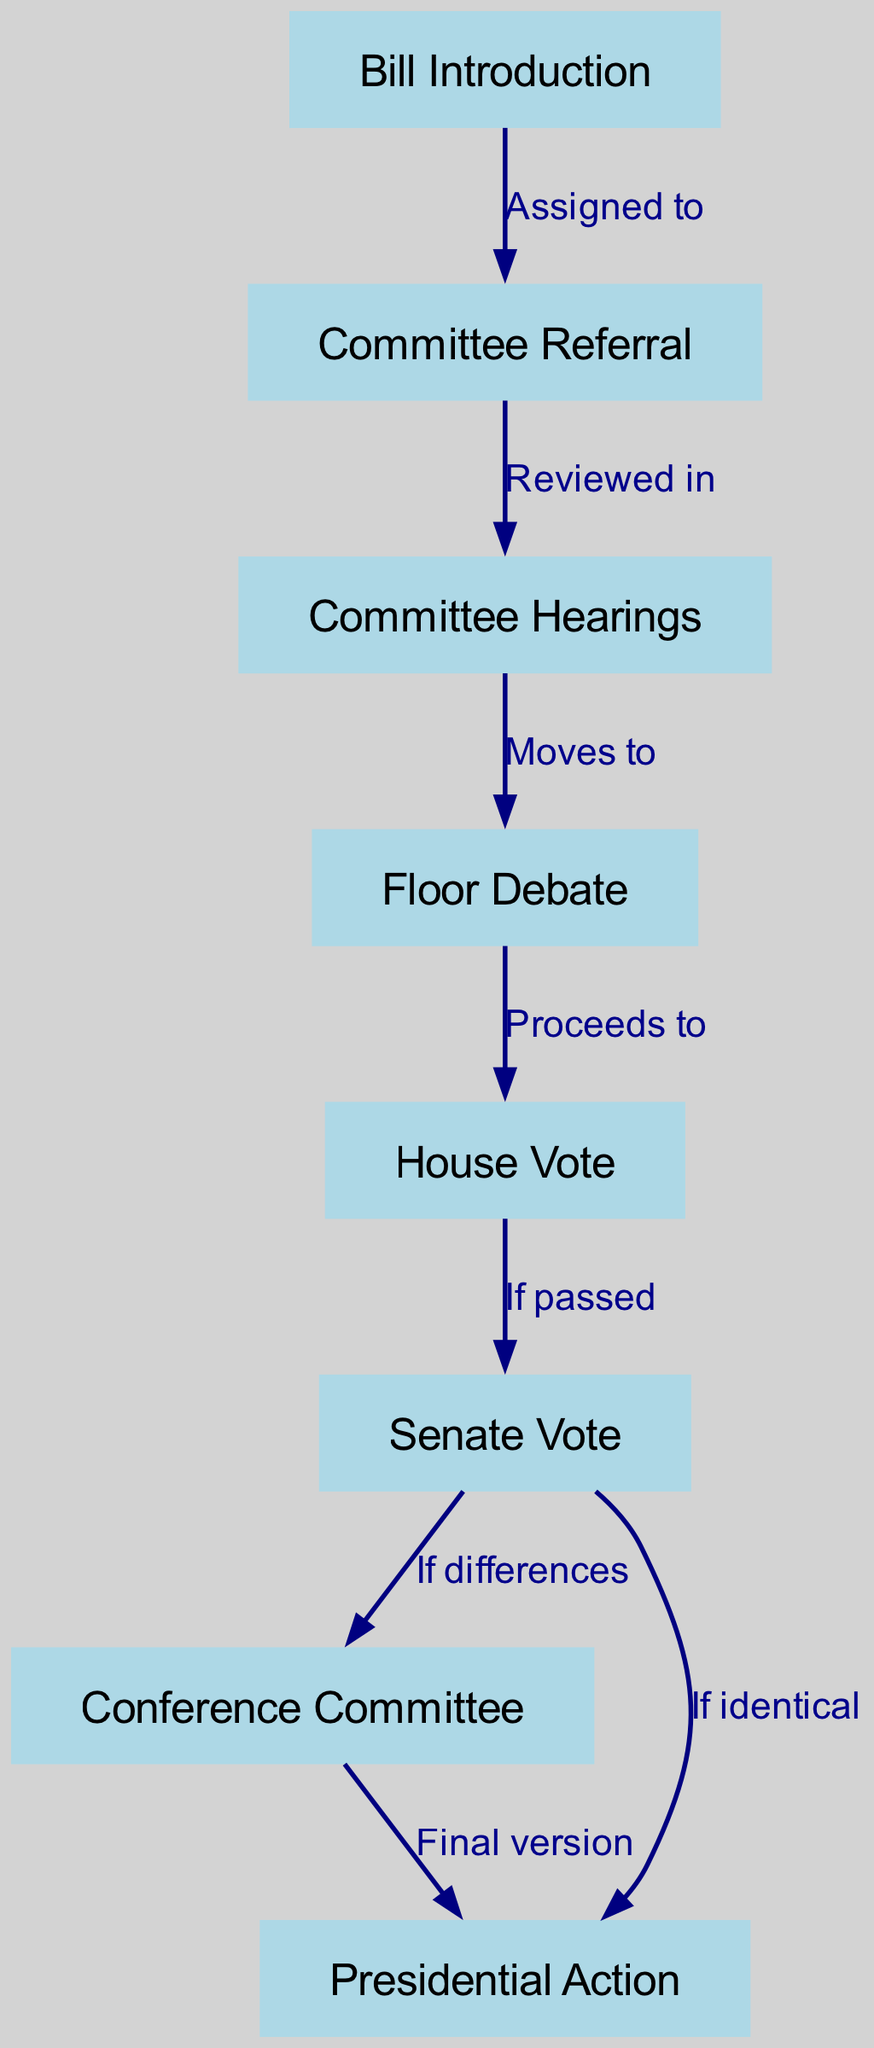What is the first step in the legislative process? According to the diagram, the first step is "Bill Introduction," indicating where the process begins.
Answer: Bill Introduction How many nodes are represented in the diagram? The diagram lists a total of 8 nodes, indicating the different stages in the legislative process.
Answer: 8 What happens after "Committee Referral"? The flow shows that after "Committee Referral," the next stage is "Committee Hearings," which means this is where the bill is reviewed.
Answer: Committee Hearings What is the label for the edge connecting "House Vote" and "Senate Vote"? The edge from "House Vote" to "Senate Vote" is labeled "If passed," suggesting that the bill needs to pass the House to proceed to the Senate.
Answer: If passed What occurs if differences are found in the Senate Vote? The diagram indicates that if differences arise, the process moves to "Conference Committee," which is where the final version of the bill is negotiated.
Answer: Conference Committee Which node connects directly to "Presidential Action"? The diagram shows two nodes that connect to "Presidential Action": one from "Conference Committee" and another directly from "Senate Vote" if the votes are identical.
Answer: Conference Committee, Senate Vote How many paths lead from "Senate Vote" to the next stage? There are two paths leading from "Senate Vote": one to "Conference Committee" (if differences) and another to "Presidential Action" (if identical), confirming that there are two possible outcomes.
Answer: 2 What does "Final version" refer to in this context? The term "Final version" refers to the output of the "Conference Committee," which is the last opportunity for the legislature to reconcile differences before submitting the bill to the president.
Answer: Final version 